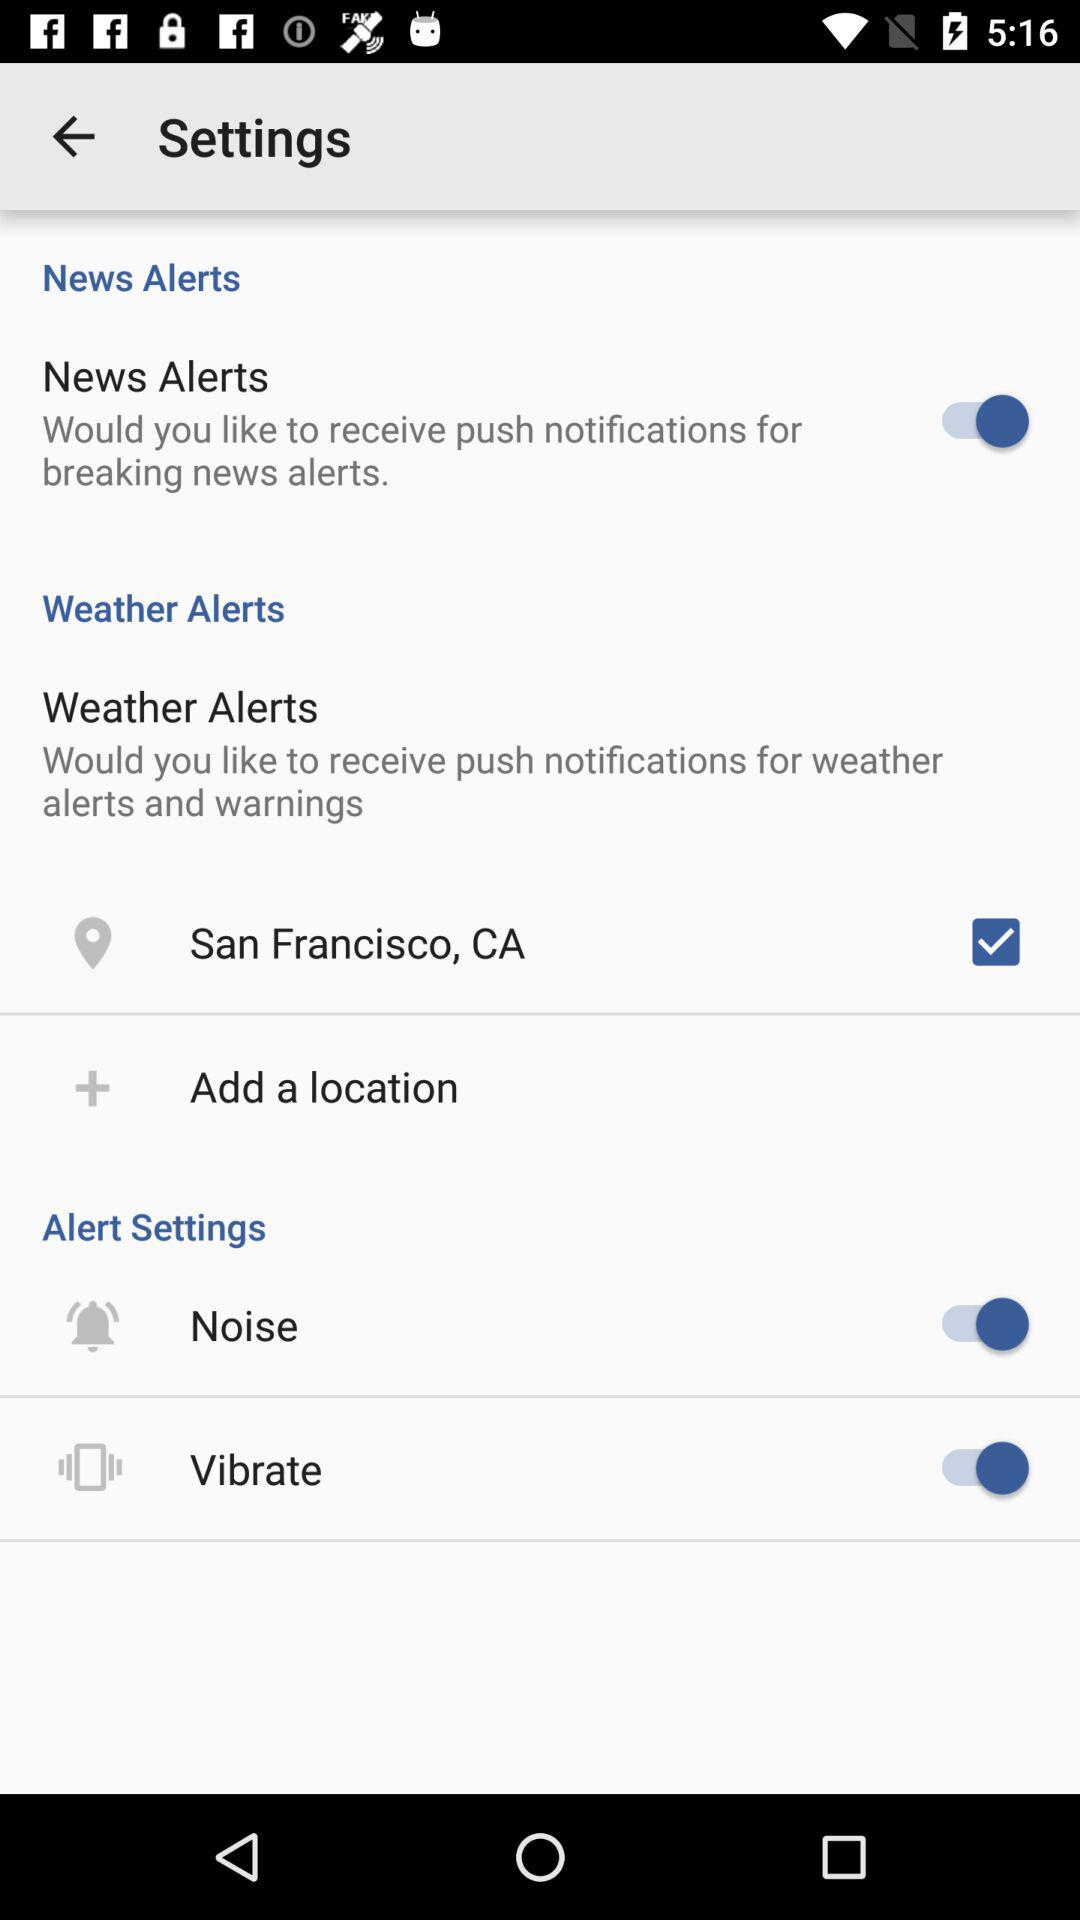What is the current location? The current location is San Francisco, CA. 